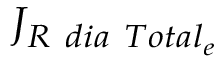Convert formula to latex. <formula><loc_0><loc_0><loc_500><loc_500>{ J } _ { R \ d i a \ T o t a l _ { e } }</formula> 